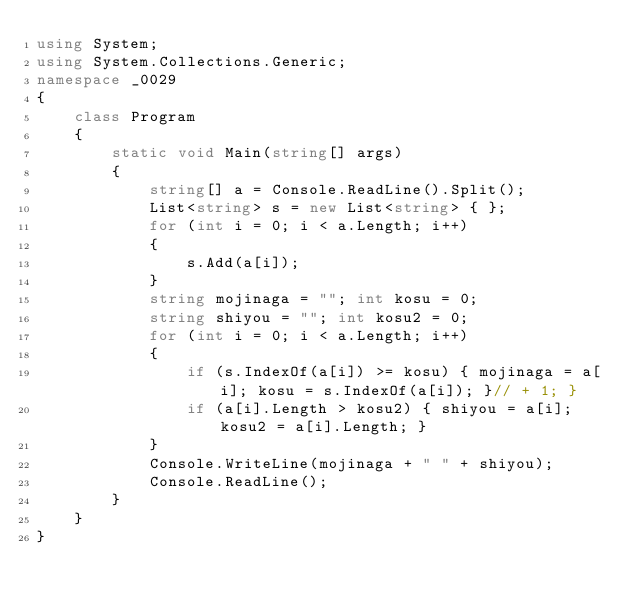Convert code to text. <code><loc_0><loc_0><loc_500><loc_500><_C#_>using System;
using System.Collections.Generic;
namespace _0029
{
    class Program
    {
        static void Main(string[] args)
        {
            string[] a = Console.ReadLine().Split();
            List<string> s = new List<string> { };
            for (int i = 0; i < a.Length; i++)
            {
                s.Add(a[i]);
            }
            string mojinaga = ""; int kosu = 0;
            string shiyou = ""; int kosu2 = 0;
            for (int i = 0; i < a.Length; i++)
            {
                if (s.IndexOf(a[i]) >= kosu) { mojinaga = a[i]; kosu = s.IndexOf(a[i]); }// + 1; }
                if (a[i].Length > kosu2) { shiyou = a[i]; kosu2 = a[i].Length; }
            }
            Console.WriteLine(mojinaga + " " + shiyou);
            Console.ReadLine();
        }
    }
}</code> 